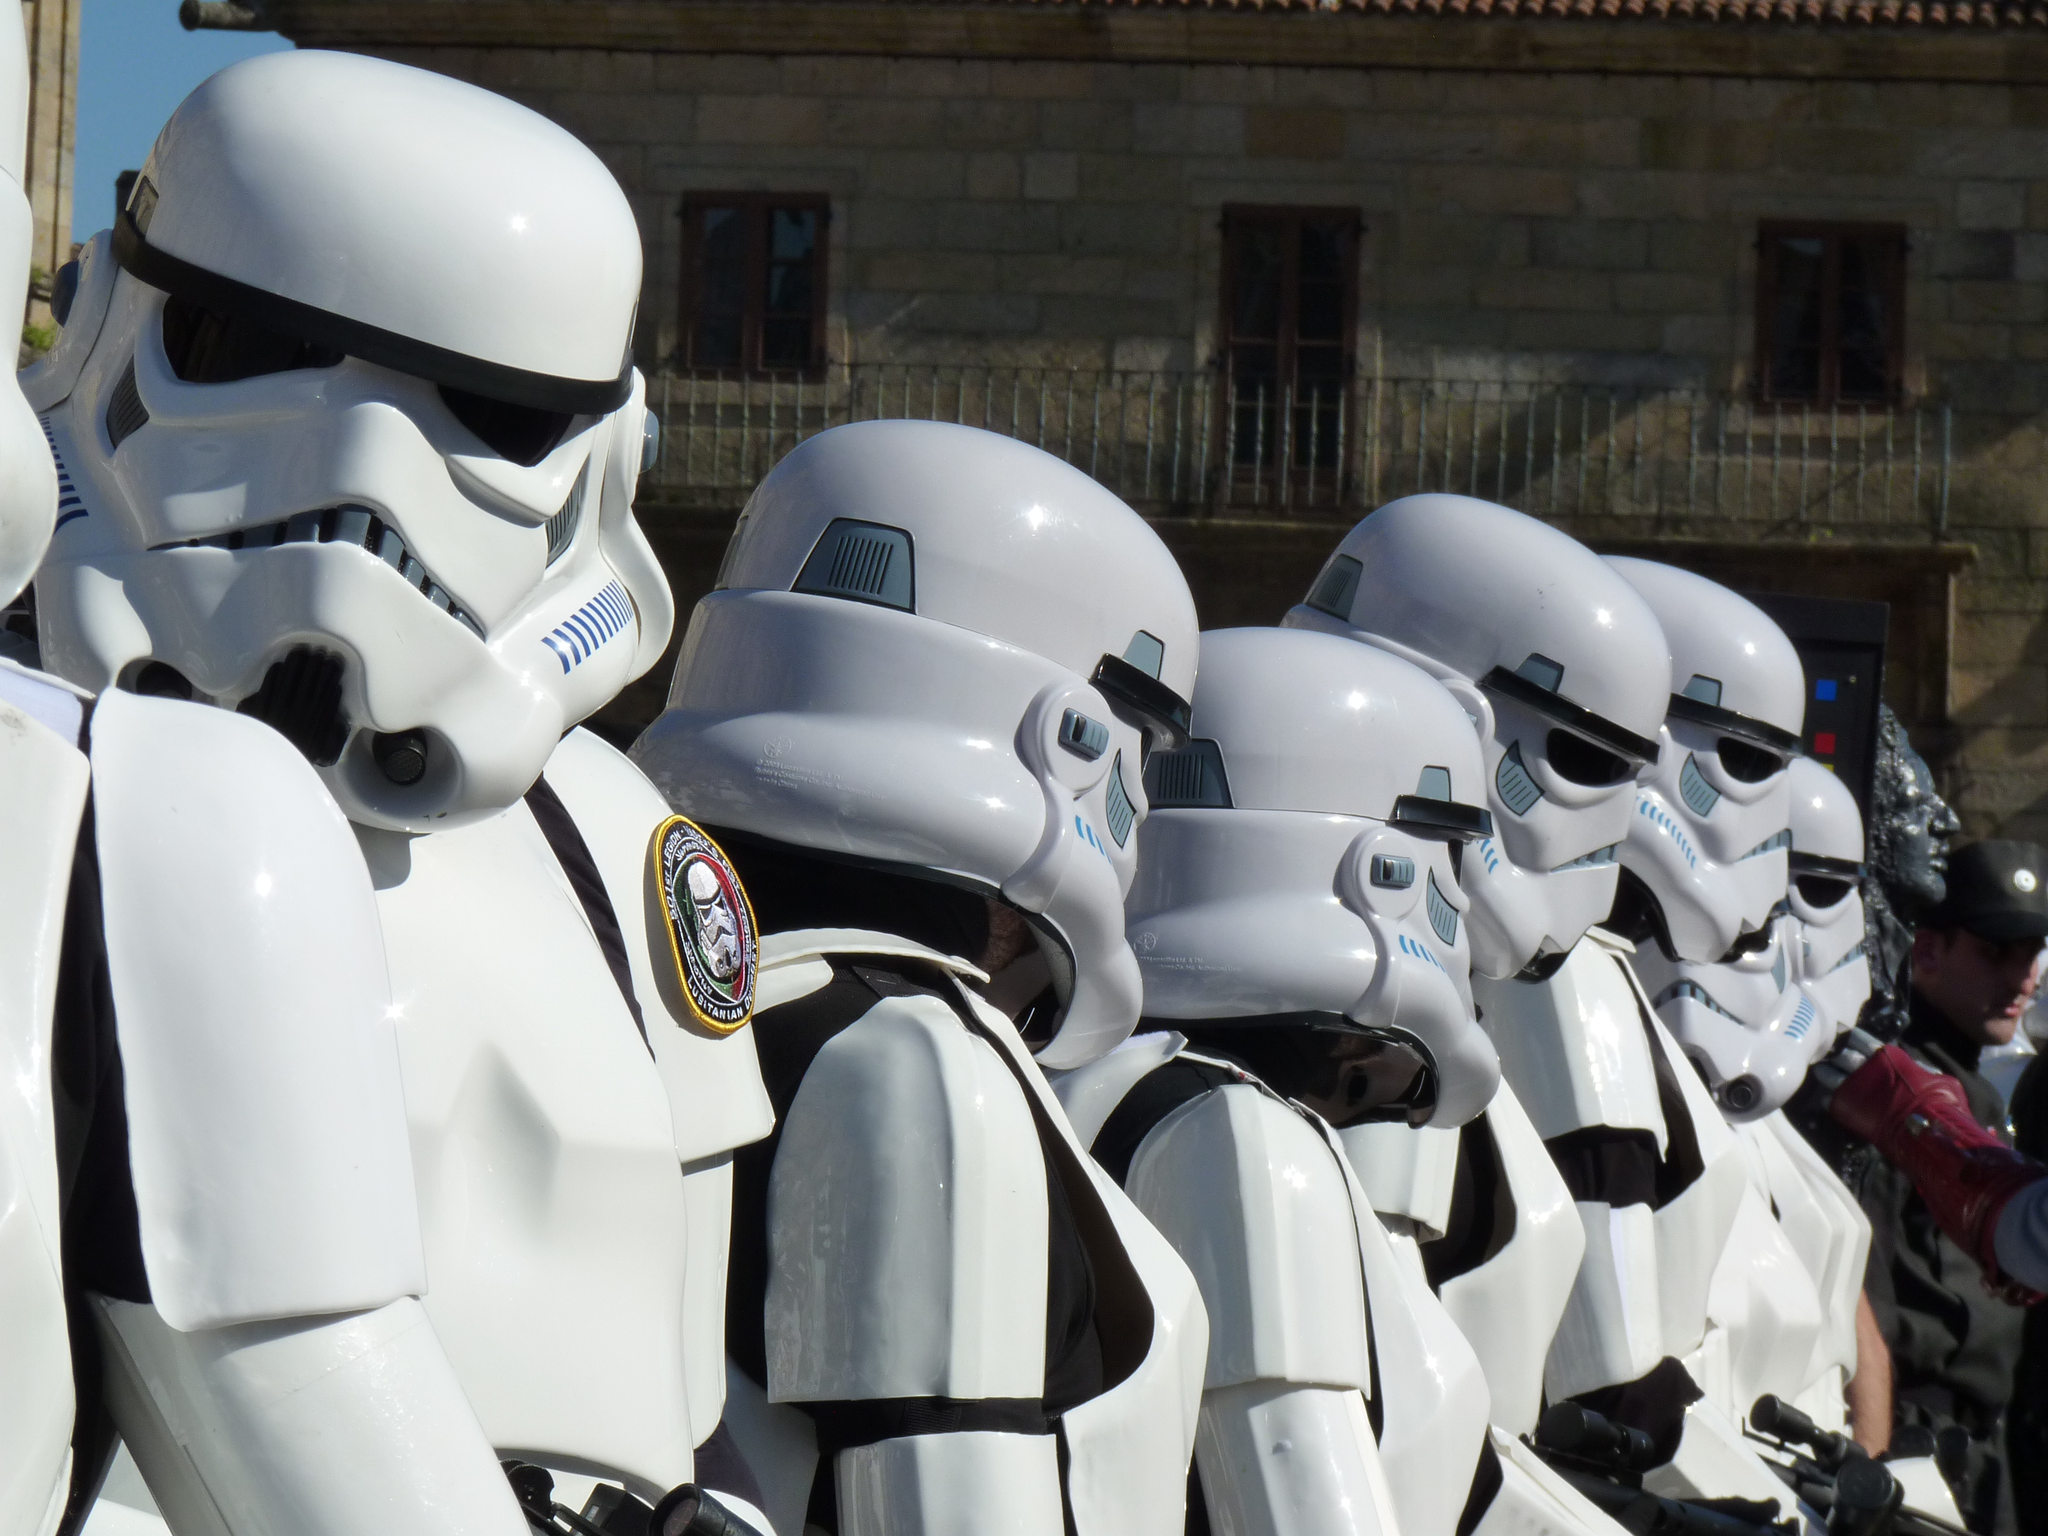How would you summarize this image in a sentence or two? There are statues at the bottom of this image and there is a building in the background. 